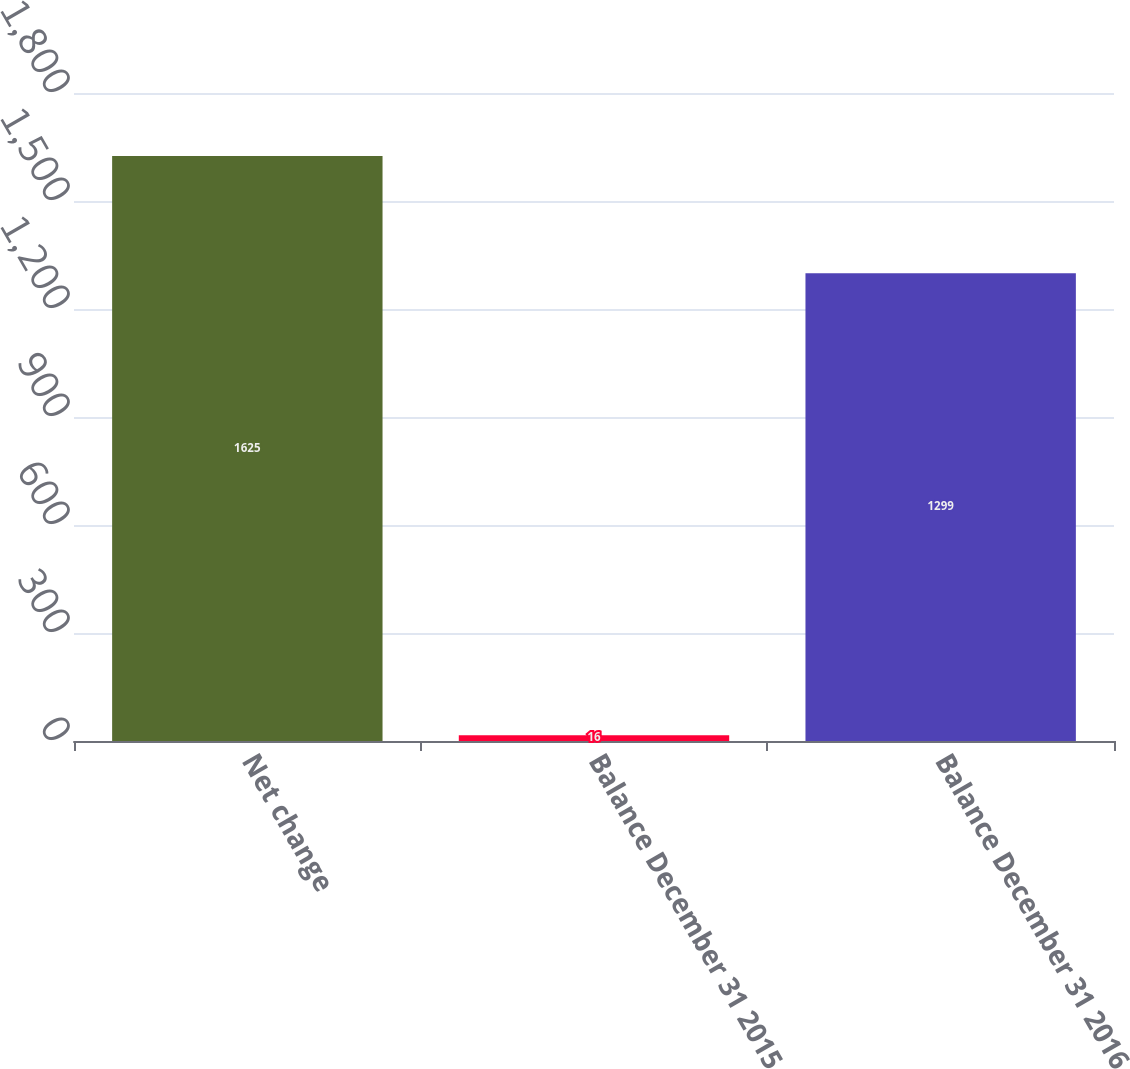<chart> <loc_0><loc_0><loc_500><loc_500><bar_chart><fcel>Net change<fcel>Balance December 31 2015<fcel>Balance December 31 2016<nl><fcel>1625<fcel>16<fcel>1299<nl></chart> 